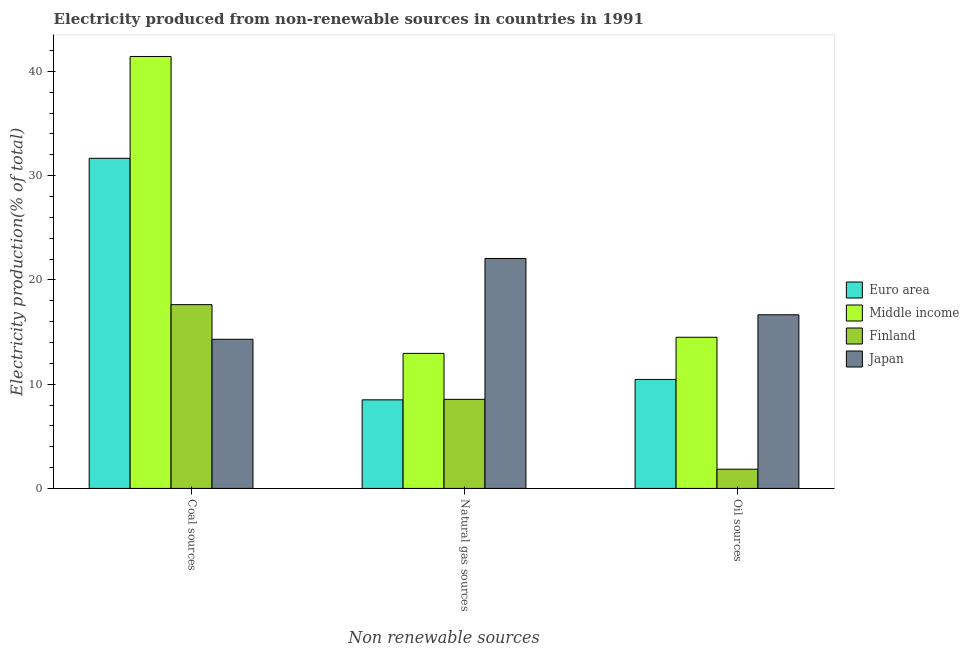Are the number of bars per tick equal to the number of legend labels?
Offer a very short reply. Yes. Are the number of bars on each tick of the X-axis equal?
Offer a very short reply. Yes. How many bars are there on the 3rd tick from the left?
Provide a short and direct response. 4. How many bars are there on the 2nd tick from the right?
Provide a short and direct response. 4. What is the label of the 1st group of bars from the left?
Keep it short and to the point. Coal sources. What is the percentage of electricity produced by coal in Finland?
Offer a very short reply. 17.62. Across all countries, what is the maximum percentage of electricity produced by coal?
Provide a succinct answer. 41.43. Across all countries, what is the minimum percentage of electricity produced by coal?
Keep it short and to the point. 14.3. What is the total percentage of electricity produced by coal in the graph?
Your answer should be very brief. 105.02. What is the difference between the percentage of electricity produced by oil sources in Japan and that in Finland?
Provide a succinct answer. 14.81. What is the difference between the percentage of electricity produced by natural gas in Euro area and the percentage of electricity produced by oil sources in Middle income?
Offer a terse response. -6. What is the average percentage of electricity produced by natural gas per country?
Your answer should be compact. 13.01. What is the difference between the percentage of electricity produced by oil sources and percentage of electricity produced by natural gas in Finland?
Provide a short and direct response. -6.7. In how many countries, is the percentage of electricity produced by oil sources greater than 24 %?
Your answer should be very brief. 0. What is the ratio of the percentage of electricity produced by natural gas in Finland to that in Middle income?
Provide a succinct answer. 0.66. Is the percentage of electricity produced by oil sources in Middle income less than that in Japan?
Keep it short and to the point. Yes. Is the difference between the percentage of electricity produced by coal in Japan and Euro area greater than the difference between the percentage of electricity produced by natural gas in Japan and Euro area?
Your answer should be compact. No. What is the difference between the highest and the second highest percentage of electricity produced by coal?
Your answer should be very brief. 9.77. What is the difference between the highest and the lowest percentage of electricity produced by oil sources?
Provide a succinct answer. 14.81. In how many countries, is the percentage of electricity produced by coal greater than the average percentage of electricity produced by coal taken over all countries?
Offer a terse response. 2. Is the sum of the percentage of electricity produced by natural gas in Middle income and Japan greater than the maximum percentage of electricity produced by oil sources across all countries?
Keep it short and to the point. Yes. What does the 3rd bar from the left in Natural gas sources represents?
Offer a terse response. Finland. Is it the case that in every country, the sum of the percentage of electricity produced by coal and percentage of electricity produced by natural gas is greater than the percentage of electricity produced by oil sources?
Make the answer very short. Yes. How many bars are there?
Keep it short and to the point. 12. Are all the bars in the graph horizontal?
Your answer should be compact. No. How many countries are there in the graph?
Make the answer very short. 4. What is the difference between two consecutive major ticks on the Y-axis?
Offer a very short reply. 10. Does the graph contain grids?
Make the answer very short. No. How many legend labels are there?
Your answer should be compact. 4. How are the legend labels stacked?
Provide a short and direct response. Vertical. What is the title of the graph?
Ensure brevity in your answer.  Electricity produced from non-renewable sources in countries in 1991. Does "St. Martin (French part)" appear as one of the legend labels in the graph?
Give a very brief answer. No. What is the label or title of the X-axis?
Offer a terse response. Non renewable sources. What is the Electricity production(% of total) of Euro area in Coal sources?
Ensure brevity in your answer.  31.66. What is the Electricity production(% of total) in Middle income in Coal sources?
Your response must be concise. 41.43. What is the Electricity production(% of total) of Finland in Coal sources?
Give a very brief answer. 17.62. What is the Electricity production(% of total) of Japan in Coal sources?
Give a very brief answer. 14.3. What is the Electricity production(% of total) in Euro area in Natural gas sources?
Provide a succinct answer. 8.5. What is the Electricity production(% of total) in Middle income in Natural gas sources?
Offer a very short reply. 12.95. What is the Electricity production(% of total) of Finland in Natural gas sources?
Your response must be concise. 8.54. What is the Electricity production(% of total) in Japan in Natural gas sources?
Your response must be concise. 22.05. What is the Electricity production(% of total) in Euro area in Oil sources?
Your answer should be very brief. 10.45. What is the Electricity production(% of total) of Middle income in Oil sources?
Your answer should be compact. 14.5. What is the Electricity production(% of total) of Finland in Oil sources?
Offer a very short reply. 1.84. What is the Electricity production(% of total) in Japan in Oil sources?
Your answer should be very brief. 16.65. Across all Non renewable sources, what is the maximum Electricity production(% of total) in Euro area?
Make the answer very short. 31.66. Across all Non renewable sources, what is the maximum Electricity production(% of total) in Middle income?
Keep it short and to the point. 41.43. Across all Non renewable sources, what is the maximum Electricity production(% of total) of Finland?
Your answer should be compact. 17.62. Across all Non renewable sources, what is the maximum Electricity production(% of total) in Japan?
Offer a very short reply. 22.05. Across all Non renewable sources, what is the minimum Electricity production(% of total) of Euro area?
Provide a succinct answer. 8.5. Across all Non renewable sources, what is the minimum Electricity production(% of total) of Middle income?
Your answer should be compact. 12.95. Across all Non renewable sources, what is the minimum Electricity production(% of total) of Finland?
Your answer should be very brief. 1.84. Across all Non renewable sources, what is the minimum Electricity production(% of total) in Japan?
Give a very brief answer. 14.3. What is the total Electricity production(% of total) of Euro area in the graph?
Offer a very short reply. 50.61. What is the total Electricity production(% of total) in Middle income in the graph?
Ensure brevity in your answer.  68.87. What is the total Electricity production(% of total) in Finland in the graph?
Your answer should be very brief. 28.01. What is the total Electricity production(% of total) of Japan in the graph?
Offer a very short reply. 53.01. What is the difference between the Electricity production(% of total) in Euro area in Coal sources and that in Natural gas sources?
Provide a short and direct response. 23.17. What is the difference between the Electricity production(% of total) of Middle income in Coal sources and that in Natural gas sources?
Provide a short and direct response. 28.48. What is the difference between the Electricity production(% of total) in Finland in Coal sources and that in Natural gas sources?
Provide a succinct answer. 9.08. What is the difference between the Electricity production(% of total) of Japan in Coal sources and that in Natural gas sources?
Offer a very short reply. -7.75. What is the difference between the Electricity production(% of total) of Euro area in Coal sources and that in Oil sources?
Offer a very short reply. 21.21. What is the difference between the Electricity production(% of total) of Middle income in Coal sources and that in Oil sources?
Your answer should be very brief. 26.93. What is the difference between the Electricity production(% of total) of Finland in Coal sources and that in Oil sources?
Offer a very short reply. 15.78. What is the difference between the Electricity production(% of total) in Japan in Coal sources and that in Oil sources?
Offer a very short reply. -2.35. What is the difference between the Electricity production(% of total) in Euro area in Natural gas sources and that in Oil sources?
Ensure brevity in your answer.  -1.96. What is the difference between the Electricity production(% of total) of Middle income in Natural gas sources and that in Oil sources?
Offer a terse response. -1.54. What is the difference between the Electricity production(% of total) of Finland in Natural gas sources and that in Oil sources?
Your response must be concise. 6.7. What is the difference between the Electricity production(% of total) of Japan in Natural gas sources and that in Oil sources?
Your answer should be very brief. 5.4. What is the difference between the Electricity production(% of total) of Euro area in Coal sources and the Electricity production(% of total) of Middle income in Natural gas sources?
Your answer should be compact. 18.71. What is the difference between the Electricity production(% of total) of Euro area in Coal sources and the Electricity production(% of total) of Finland in Natural gas sources?
Your answer should be very brief. 23.12. What is the difference between the Electricity production(% of total) in Euro area in Coal sources and the Electricity production(% of total) in Japan in Natural gas sources?
Make the answer very short. 9.61. What is the difference between the Electricity production(% of total) of Middle income in Coal sources and the Electricity production(% of total) of Finland in Natural gas sources?
Provide a succinct answer. 32.88. What is the difference between the Electricity production(% of total) of Middle income in Coal sources and the Electricity production(% of total) of Japan in Natural gas sources?
Give a very brief answer. 19.37. What is the difference between the Electricity production(% of total) of Finland in Coal sources and the Electricity production(% of total) of Japan in Natural gas sources?
Offer a terse response. -4.43. What is the difference between the Electricity production(% of total) of Euro area in Coal sources and the Electricity production(% of total) of Middle income in Oil sources?
Make the answer very short. 17.17. What is the difference between the Electricity production(% of total) in Euro area in Coal sources and the Electricity production(% of total) in Finland in Oil sources?
Your answer should be compact. 29.82. What is the difference between the Electricity production(% of total) in Euro area in Coal sources and the Electricity production(% of total) in Japan in Oil sources?
Ensure brevity in your answer.  15.01. What is the difference between the Electricity production(% of total) in Middle income in Coal sources and the Electricity production(% of total) in Finland in Oil sources?
Make the answer very short. 39.58. What is the difference between the Electricity production(% of total) in Middle income in Coal sources and the Electricity production(% of total) in Japan in Oil sources?
Your answer should be compact. 24.77. What is the difference between the Electricity production(% of total) in Finland in Coal sources and the Electricity production(% of total) in Japan in Oil sources?
Your answer should be compact. 0.97. What is the difference between the Electricity production(% of total) of Euro area in Natural gas sources and the Electricity production(% of total) of Middle income in Oil sources?
Keep it short and to the point. -6. What is the difference between the Electricity production(% of total) of Euro area in Natural gas sources and the Electricity production(% of total) of Finland in Oil sources?
Provide a succinct answer. 6.65. What is the difference between the Electricity production(% of total) in Euro area in Natural gas sources and the Electricity production(% of total) in Japan in Oil sources?
Provide a short and direct response. -8.16. What is the difference between the Electricity production(% of total) of Middle income in Natural gas sources and the Electricity production(% of total) of Finland in Oil sources?
Your response must be concise. 11.11. What is the difference between the Electricity production(% of total) in Middle income in Natural gas sources and the Electricity production(% of total) in Japan in Oil sources?
Provide a succinct answer. -3.7. What is the difference between the Electricity production(% of total) of Finland in Natural gas sources and the Electricity production(% of total) of Japan in Oil sources?
Your answer should be compact. -8.11. What is the average Electricity production(% of total) of Euro area per Non renewable sources?
Your answer should be compact. 16.87. What is the average Electricity production(% of total) in Middle income per Non renewable sources?
Ensure brevity in your answer.  22.96. What is the average Electricity production(% of total) in Finland per Non renewable sources?
Keep it short and to the point. 9.34. What is the average Electricity production(% of total) in Japan per Non renewable sources?
Offer a terse response. 17.67. What is the difference between the Electricity production(% of total) of Euro area and Electricity production(% of total) of Middle income in Coal sources?
Make the answer very short. -9.77. What is the difference between the Electricity production(% of total) of Euro area and Electricity production(% of total) of Finland in Coal sources?
Your answer should be compact. 14.04. What is the difference between the Electricity production(% of total) of Euro area and Electricity production(% of total) of Japan in Coal sources?
Your answer should be compact. 17.36. What is the difference between the Electricity production(% of total) in Middle income and Electricity production(% of total) in Finland in Coal sources?
Offer a terse response. 23.8. What is the difference between the Electricity production(% of total) in Middle income and Electricity production(% of total) in Japan in Coal sources?
Offer a terse response. 27.12. What is the difference between the Electricity production(% of total) in Finland and Electricity production(% of total) in Japan in Coal sources?
Give a very brief answer. 3.32. What is the difference between the Electricity production(% of total) in Euro area and Electricity production(% of total) in Middle income in Natural gas sources?
Give a very brief answer. -4.46. What is the difference between the Electricity production(% of total) in Euro area and Electricity production(% of total) in Finland in Natural gas sources?
Provide a short and direct response. -0.05. What is the difference between the Electricity production(% of total) in Euro area and Electricity production(% of total) in Japan in Natural gas sources?
Provide a short and direct response. -13.56. What is the difference between the Electricity production(% of total) in Middle income and Electricity production(% of total) in Finland in Natural gas sources?
Keep it short and to the point. 4.41. What is the difference between the Electricity production(% of total) of Middle income and Electricity production(% of total) of Japan in Natural gas sources?
Offer a very short reply. -9.1. What is the difference between the Electricity production(% of total) in Finland and Electricity production(% of total) in Japan in Natural gas sources?
Offer a terse response. -13.51. What is the difference between the Electricity production(% of total) in Euro area and Electricity production(% of total) in Middle income in Oil sources?
Keep it short and to the point. -4.04. What is the difference between the Electricity production(% of total) in Euro area and Electricity production(% of total) in Finland in Oil sources?
Your answer should be compact. 8.61. What is the difference between the Electricity production(% of total) in Euro area and Electricity production(% of total) in Japan in Oil sources?
Your answer should be compact. -6.2. What is the difference between the Electricity production(% of total) in Middle income and Electricity production(% of total) in Finland in Oil sources?
Your answer should be compact. 12.65. What is the difference between the Electricity production(% of total) in Middle income and Electricity production(% of total) in Japan in Oil sources?
Your answer should be compact. -2.16. What is the difference between the Electricity production(% of total) of Finland and Electricity production(% of total) of Japan in Oil sources?
Your response must be concise. -14.81. What is the ratio of the Electricity production(% of total) in Euro area in Coal sources to that in Natural gas sources?
Ensure brevity in your answer.  3.73. What is the ratio of the Electricity production(% of total) in Middle income in Coal sources to that in Natural gas sources?
Keep it short and to the point. 3.2. What is the ratio of the Electricity production(% of total) of Finland in Coal sources to that in Natural gas sources?
Make the answer very short. 2.06. What is the ratio of the Electricity production(% of total) of Japan in Coal sources to that in Natural gas sources?
Your response must be concise. 0.65. What is the ratio of the Electricity production(% of total) in Euro area in Coal sources to that in Oil sources?
Offer a very short reply. 3.03. What is the ratio of the Electricity production(% of total) of Middle income in Coal sources to that in Oil sources?
Keep it short and to the point. 2.86. What is the ratio of the Electricity production(% of total) of Finland in Coal sources to that in Oil sources?
Provide a succinct answer. 9.56. What is the ratio of the Electricity production(% of total) in Japan in Coal sources to that in Oil sources?
Offer a very short reply. 0.86. What is the ratio of the Electricity production(% of total) in Euro area in Natural gas sources to that in Oil sources?
Your answer should be very brief. 0.81. What is the ratio of the Electricity production(% of total) in Middle income in Natural gas sources to that in Oil sources?
Offer a very short reply. 0.89. What is the ratio of the Electricity production(% of total) of Finland in Natural gas sources to that in Oil sources?
Provide a short and direct response. 4.63. What is the ratio of the Electricity production(% of total) in Japan in Natural gas sources to that in Oil sources?
Make the answer very short. 1.32. What is the difference between the highest and the second highest Electricity production(% of total) in Euro area?
Your response must be concise. 21.21. What is the difference between the highest and the second highest Electricity production(% of total) in Middle income?
Ensure brevity in your answer.  26.93. What is the difference between the highest and the second highest Electricity production(% of total) in Finland?
Make the answer very short. 9.08. What is the difference between the highest and the second highest Electricity production(% of total) of Japan?
Provide a short and direct response. 5.4. What is the difference between the highest and the lowest Electricity production(% of total) of Euro area?
Offer a very short reply. 23.17. What is the difference between the highest and the lowest Electricity production(% of total) in Middle income?
Keep it short and to the point. 28.48. What is the difference between the highest and the lowest Electricity production(% of total) in Finland?
Your answer should be very brief. 15.78. What is the difference between the highest and the lowest Electricity production(% of total) of Japan?
Ensure brevity in your answer.  7.75. 